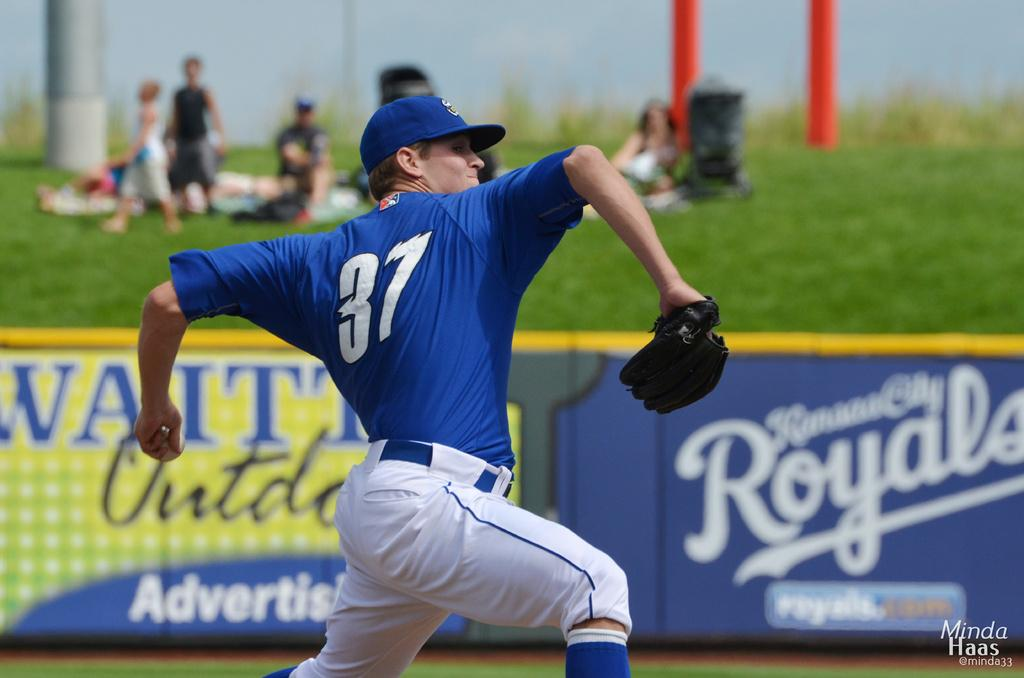<image>
Render a clear and concise summary of the photo. A pitcher in a baseball game in his delivery and a Royals advertisement in the background. 